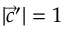<formula> <loc_0><loc_0><loc_500><loc_500>\, | { \vec { c } } ^ { \prime } | = 1</formula> 